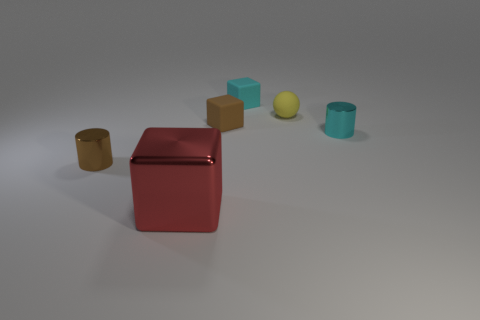Are there any other things that have the same material as the red object?
Make the answer very short. Yes. There is a small metal object on the right side of the red thing; is there a small brown thing that is behind it?
Provide a succinct answer. Yes. How many objects are matte things that are to the right of the large shiny object or tiny spheres on the right side of the small brown metal cylinder?
Your answer should be compact. 3. Is there any other thing of the same color as the large metal thing?
Ensure brevity in your answer.  No. There is a block to the right of the rubber cube to the left of the small rubber block behind the small yellow rubber thing; what is its color?
Provide a short and direct response. Cyan. How big is the cube that is in front of the shiny object behind the tiny brown cylinder?
Offer a terse response. Large. What material is the small thing that is both in front of the small brown rubber thing and left of the tiny yellow object?
Provide a short and direct response. Metal. There is a yellow matte ball; is it the same size as the rubber object that is left of the cyan block?
Offer a very short reply. Yes. Is there a tiny metal thing?
Ensure brevity in your answer.  Yes. There is another small thing that is the same shape as the cyan shiny thing; what is its material?
Make the answer very short. Metal. 